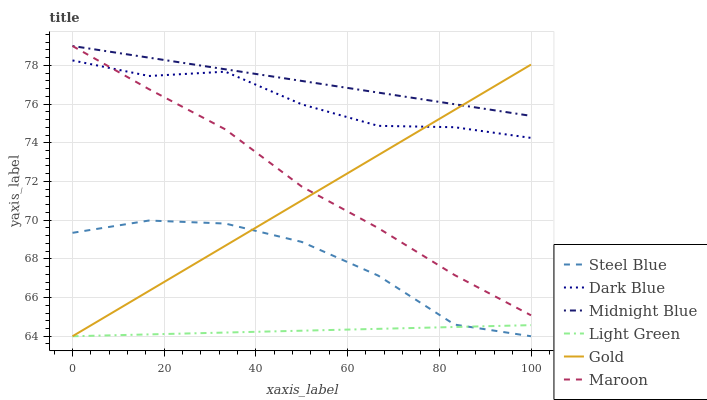Does Light Green have the minimum area under the curve?
Answer yes or no. Yes. Does Midnight Blue have the maximum area under the curve?
Answer yes or no. Yes. Does Gold have the minimum area under the curve?
Answer yes or no. No. Does Gold have the maximum area under the curve?
Answer yes or no. No. Is Gold the smoothest?
Answer yes or no. Yes. Is Steel Blue the roughest?
Answer yes or no. Yes. Is Steel Blue the smoothest?
Answer yes or no. No. Is Gold the roughest?
Answer yes or no. No. Does Gold have the lowest value?
Answer yes or no. Yes. Does Maroon have the lowest value?
Answer yes or no. No. Does Maroon have the highest value?
Answer yes or no. Yes. Does Gold have the highest value?
Answer yes or no. No. Is Light Green less than Maroon?
Answer yes or no. Yes. Is Maroon greater than Light Green?
Answer yes or no. Yes. Does Gold intersect Light Green?
Answer yes or no. Yes. Is Gold less than Light Green?
Answer yes or no. No. Is Gold greater than Light Green?
Answer yes or no. No. Does Light Green intersect Maroon?
Answer yes or no. No. 